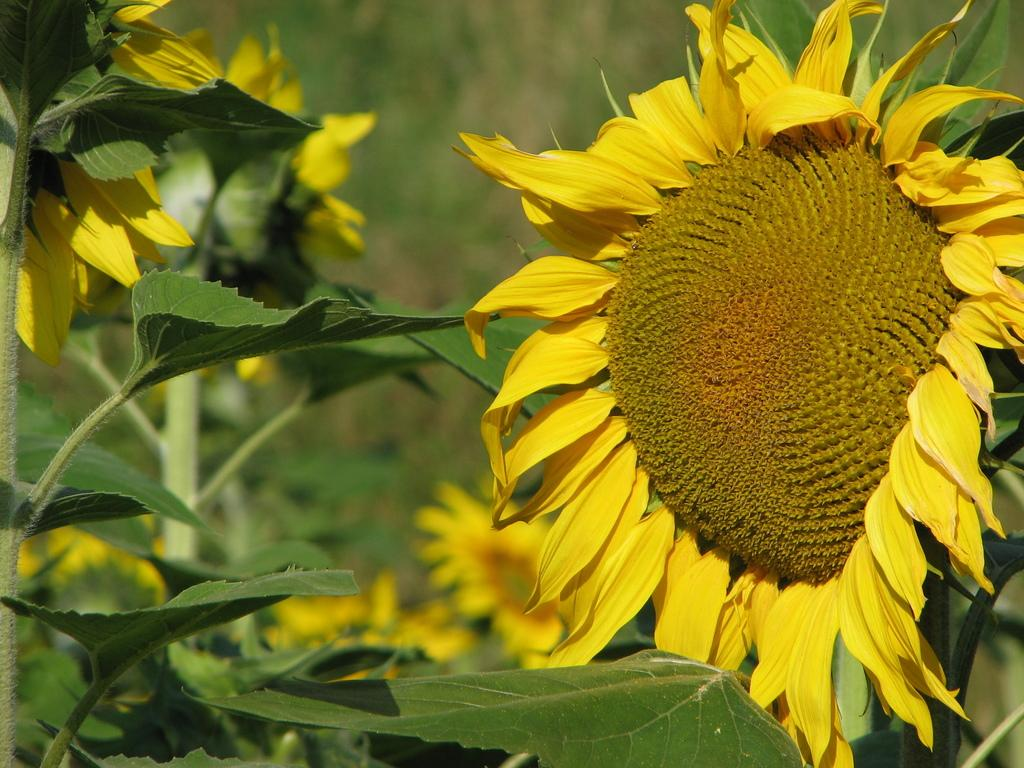What is the main subject of the image? The main subject of the image is planets. What is unique about these planets? The planets have flowers on them. Can you describe the appearance of the flowers? The flowers are yellow and brown in color. How would you describe the background of the image? The background of the image is blurred. What type of rake is being used to harvest the flowers on the planets in the image? There is no rake present in the image, and the planets are not being harvested for flowers. 